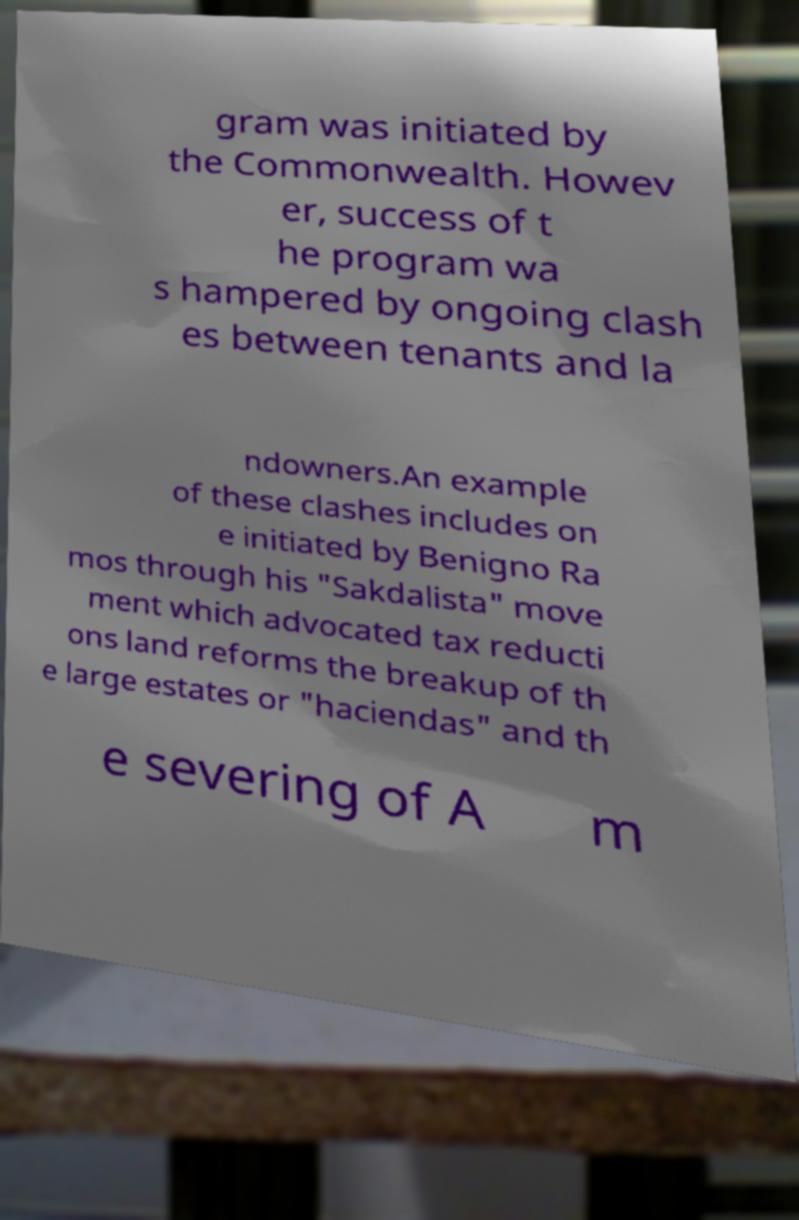Could you extract and type out the text from this image? gram was initiated by the Commonwealth. Howev er, success of t he program wa s hampered by ongoing clash es between tenants and la ndowners.An example of these clashes includes on e initiated by Benigno Ra mos through his "Sakdalista" move ment which advocated tax reducti ons land reforms the breakup of th e large estates or "haciendas" and th e severing of A m 